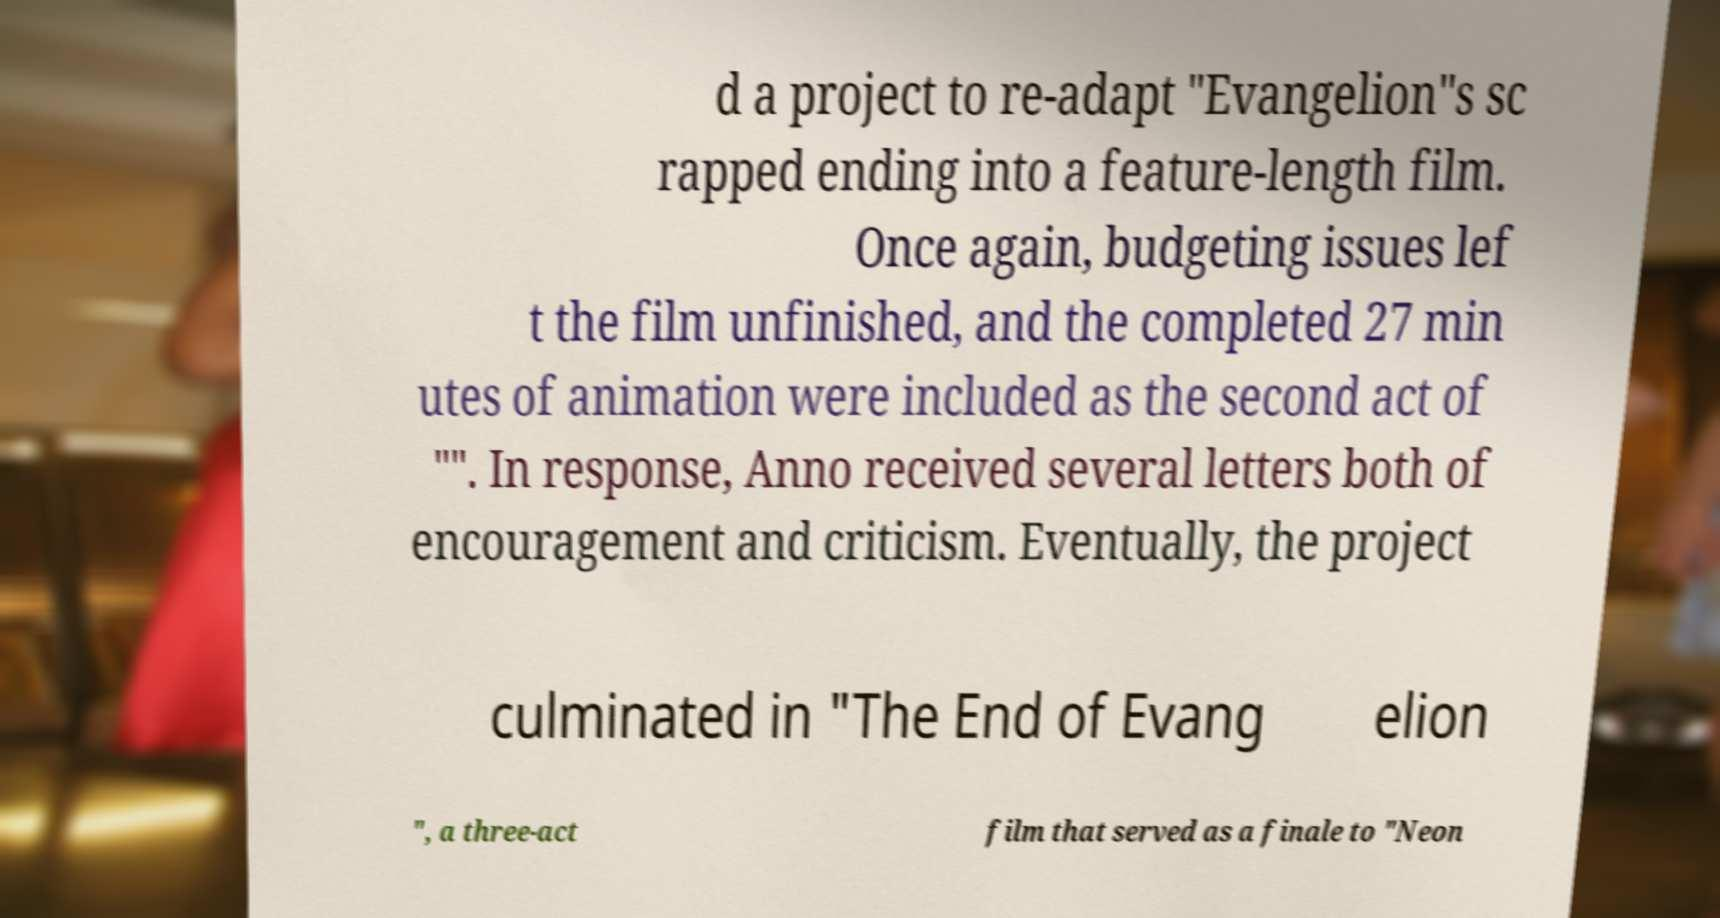What messages or text are displayed in this image? I need them in a readable, typed format. d a project to re-adapt "Evangelion"s sc rapped ending into a feature-length film. Once again, budgeting issues lef t the film unfinished, and the completed 27 min utes of animation were included as the second act of "". In response, Anno received several letters both of encouragement and criticism. Eventually, the project culminated in "The End of Evang elion ", a three-act film that served as a finale to "Neon 